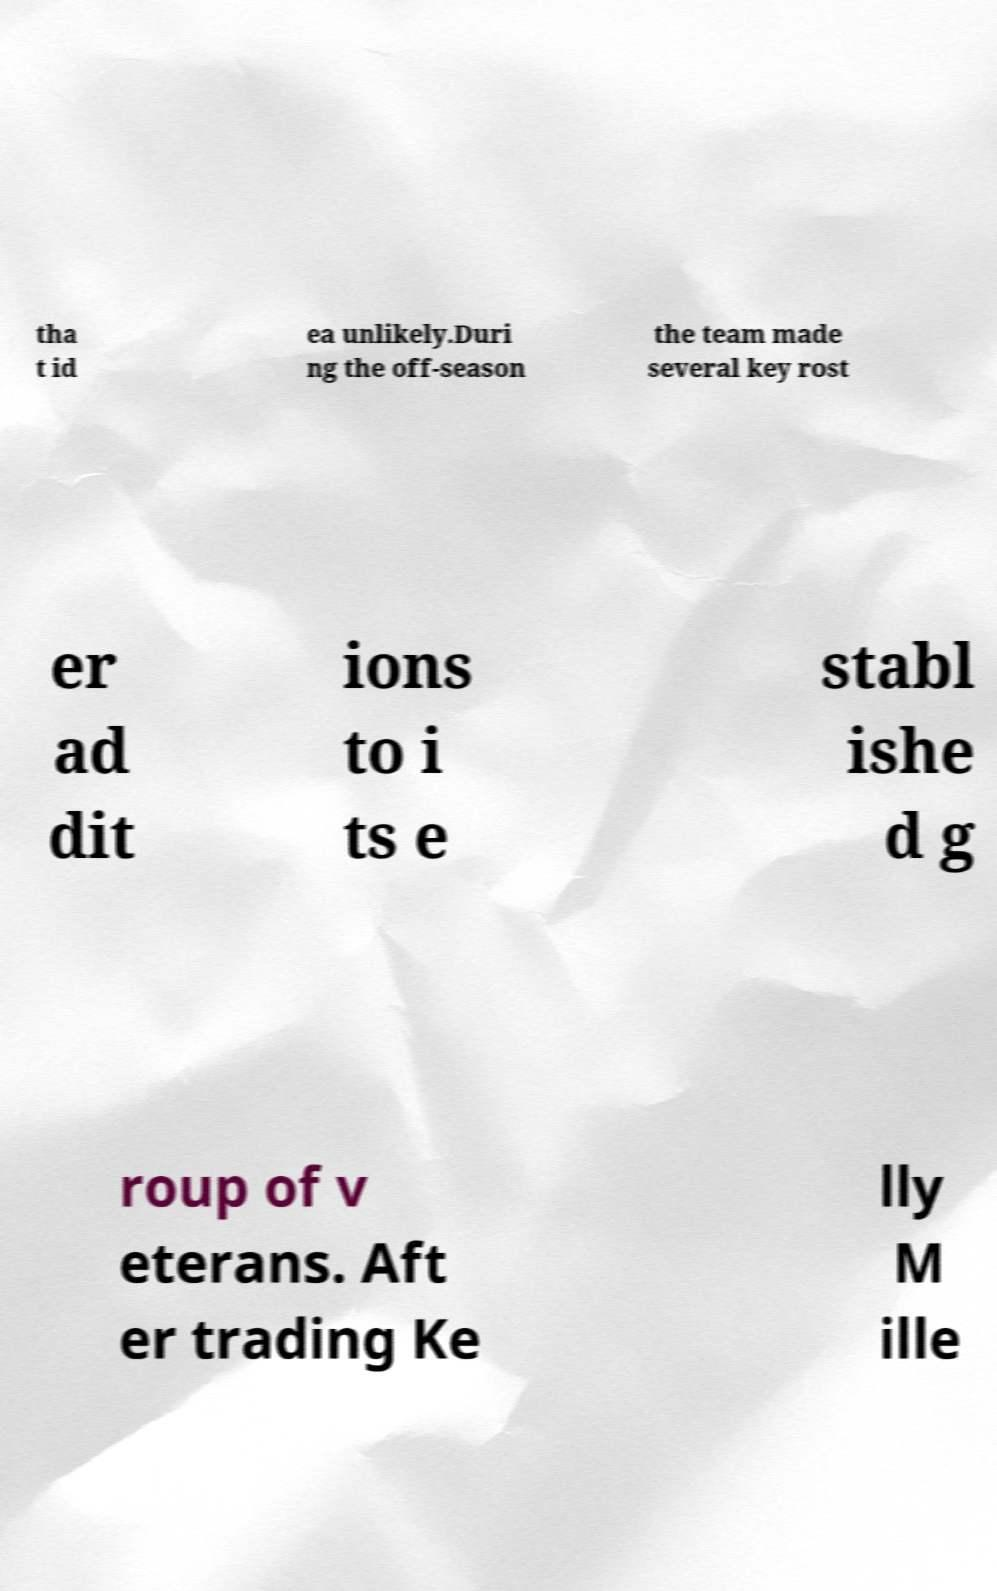Please identify and transcribe the text found in this image. tha t id ea unlikely.Duri ng the off-season the team made several key rost er ad dit ions to i ts e stabl ishe d g roup of v eterans. Aft er trading Ke lly M ille 